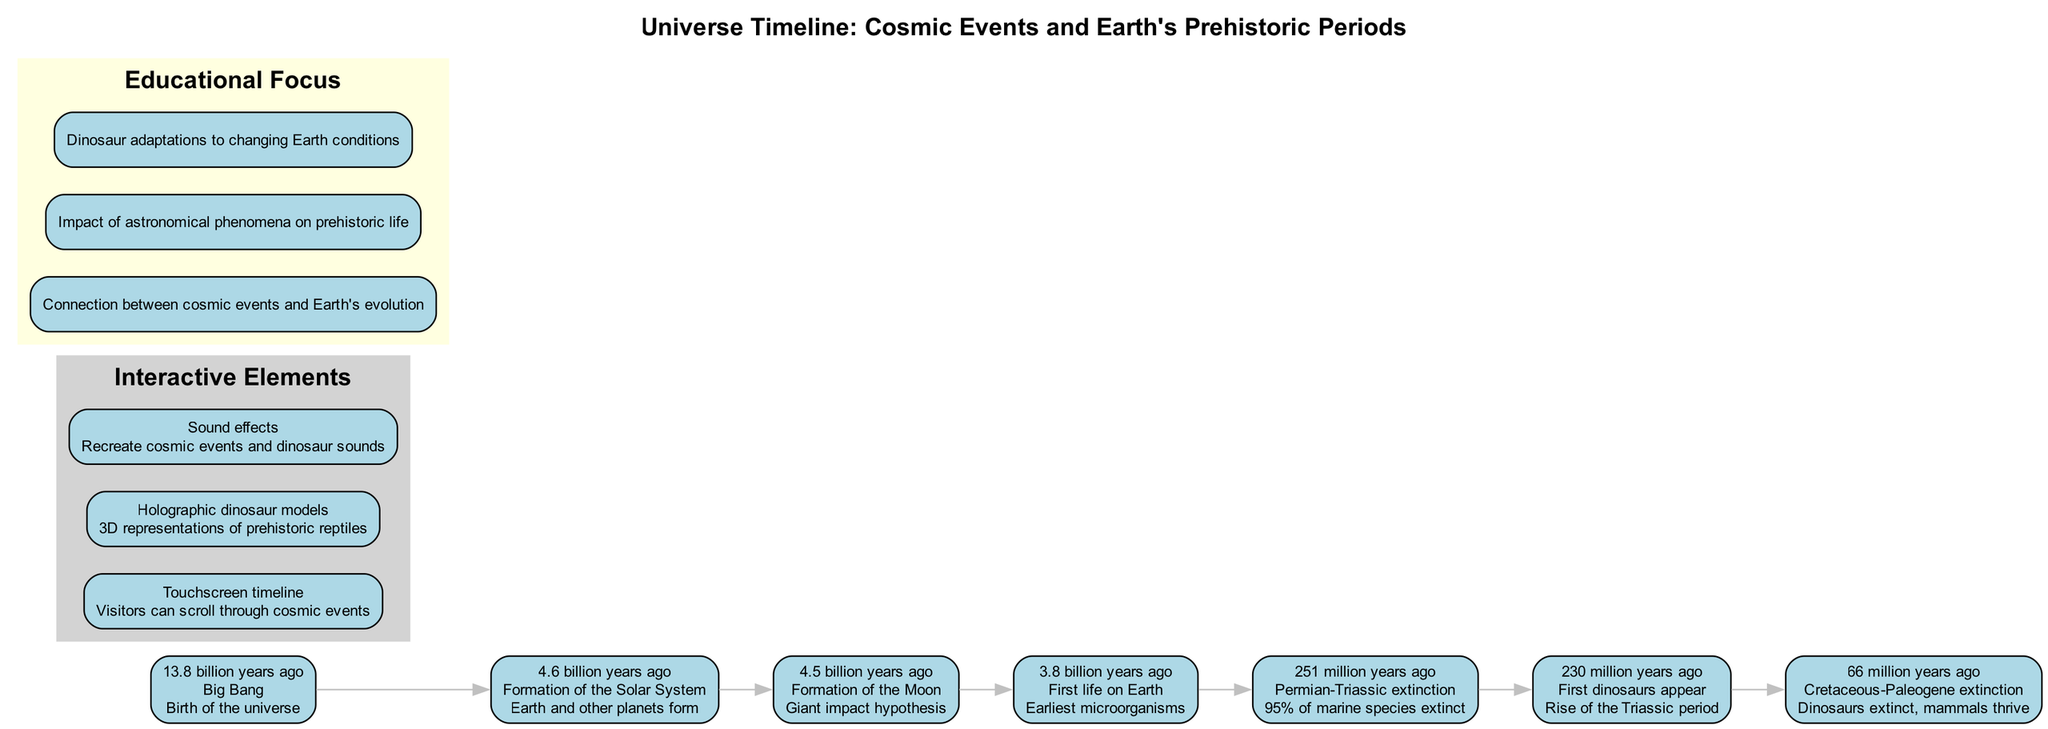What event marks the beginning of the universe? The diagram shows the Big Bang occurring 13.8 billion years ago as the first significant event in the timeline.
Answer: Big Bang How many mass extinction events are noted in the timeline? The diagram includes two major extinction events: the Permian-Triassic extinction and the Cretaceous-Paleogene extinction, which can be counted from the timeline events.
Answer: 2 What happened 4.6 billion years ago? According to the timeline, the formation of the Solar System is indicated as occurring 4.6 billion years ago.
Answer: Formation of the Solar System Which event is associated with the appearance of the first dinosaurs? The first dinosaurs appeared 230 million years ago during the rise of the Triassic period, as shown in the diagram.
Answer: First dinosaurs appear What is the time gap between the Big Bang and the formation of the Solar System? The timeline indicates that the Big Bang occurred 13.8 billion years ago and the Solar System formed 4.6 billion years ago, leading to a gap of 9.2 billion years.
Answer: 9.2 billion years What significant astronomical event is linked to the extinction of dinosaurs? The Cretaceous-Paleogene extinction, which occurred 66 million years ago, is highlighted in the timeline as the event leading to the extinction of the dinosaurs.
Answer: Cretaceous-Paleogene extinction How many key cosmic events are depicted in the timeline? The diagram lists seven key cosmic events that shape the timeline, which can be counted directly from the provided events.
Answer: 7 What kind of interactive element allows visitors to experience dinosaur sounds? The diagram specifies that sound effects are included as an interactive element that recreates both cosmic events and dinosaur sounds.
Answer: Sound effects What is the main educational focus of the diagram? The primary focus is on the connection between cosmic events and Earth's evolution, which directly links the astronomical content with the prehistoric narrative.
Answer: Connection between cosmic events and Earth's evolution 